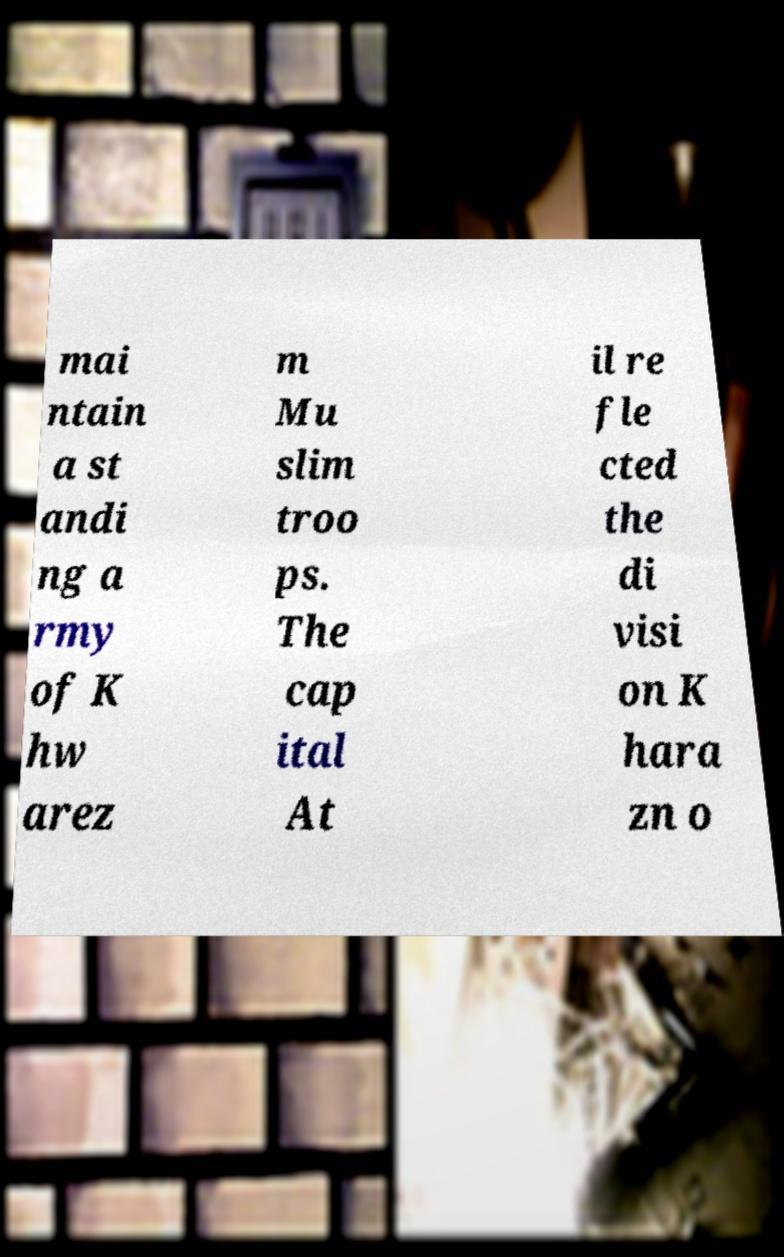Can you read and provide the text displayed in the image?This photo seems to have some interesting text. Can you extract and type it out for me? mai ntain a st andi ng a rmy of K hw arez m Mu slim troo ps. The cap ital At il re fle cted the di visi on K hara zn o 